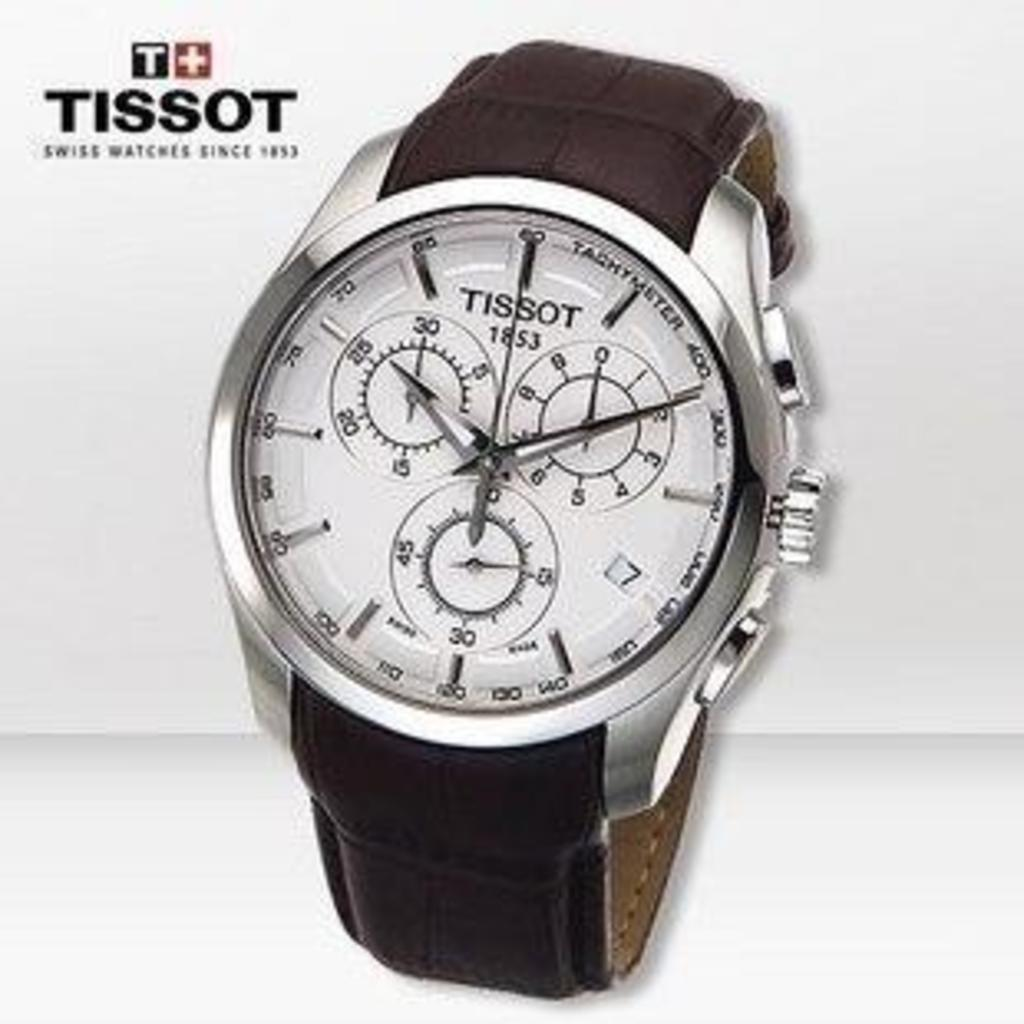Provide a one-sentence caption for the provided image. An advertisement with the image of a Tissot watch with a brown band. 